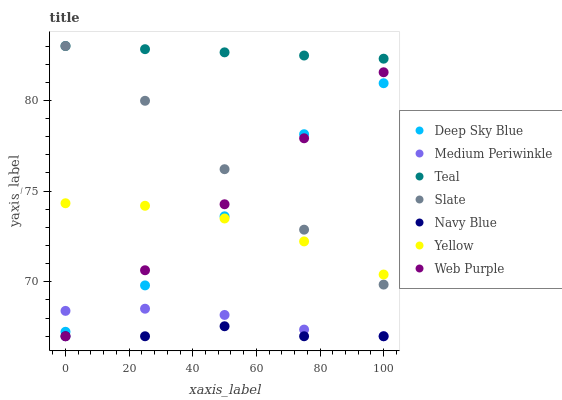Does Navy Blue have the minimum area under the curve?
Answer yes or no. Yes. Does Teal have the maximum area under the curve?
Answer yes or no. Yes. Does Slate have the minimum area under the curve?
Answer yes or no. No. Does Slate have the maximum area under the curve?
Answer yes or no. No. Is Teal the smoothest?
Answer yes or no. Yes. Is Deep Sky Blue the roughest?
Answer yes or no. Yes. Is Navy Blue the smoothest?
Answer yes or no. No. Is Navy Blue the roughest?
Answer yes or no. No. Does Navy Blue have the lowest value?
Answer yes or no. Yes. Does Slate have the lowest value?
Answer yes or no. No. Does Teal have the highest value?
Answer yes or no. Yes. Does Navy Blue have the highest value?
Answer yes or no. No. Is Deep Sky Blue less than Teal?
Answer yes or no. Yes. Is Yellow greater than Medium Periwinkle?
Answer yes or no. Yes. Does Web Purple intersect Deep Sky Blue?
Answer yes or no. Yes. Is Web Purple less than Deep Sky Blue?
Answer yes or no. No. Is Web Purple greater than Deep Sky Blue?
Answer yes or no. No. Does Deep Sky Blue intersect Teal?
Answer yes or no. No. 